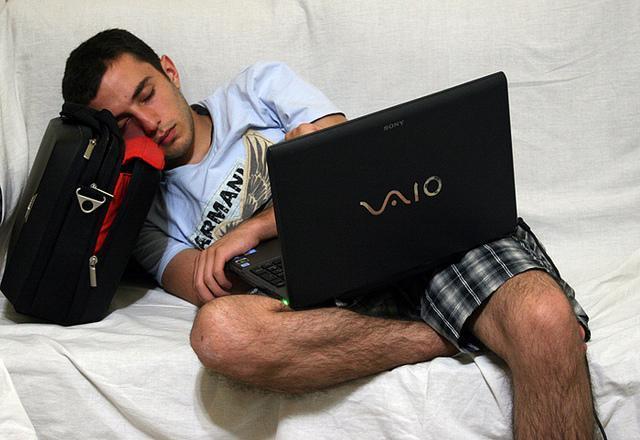How many laptops can be seen?
Give a very brief answer. 1. 